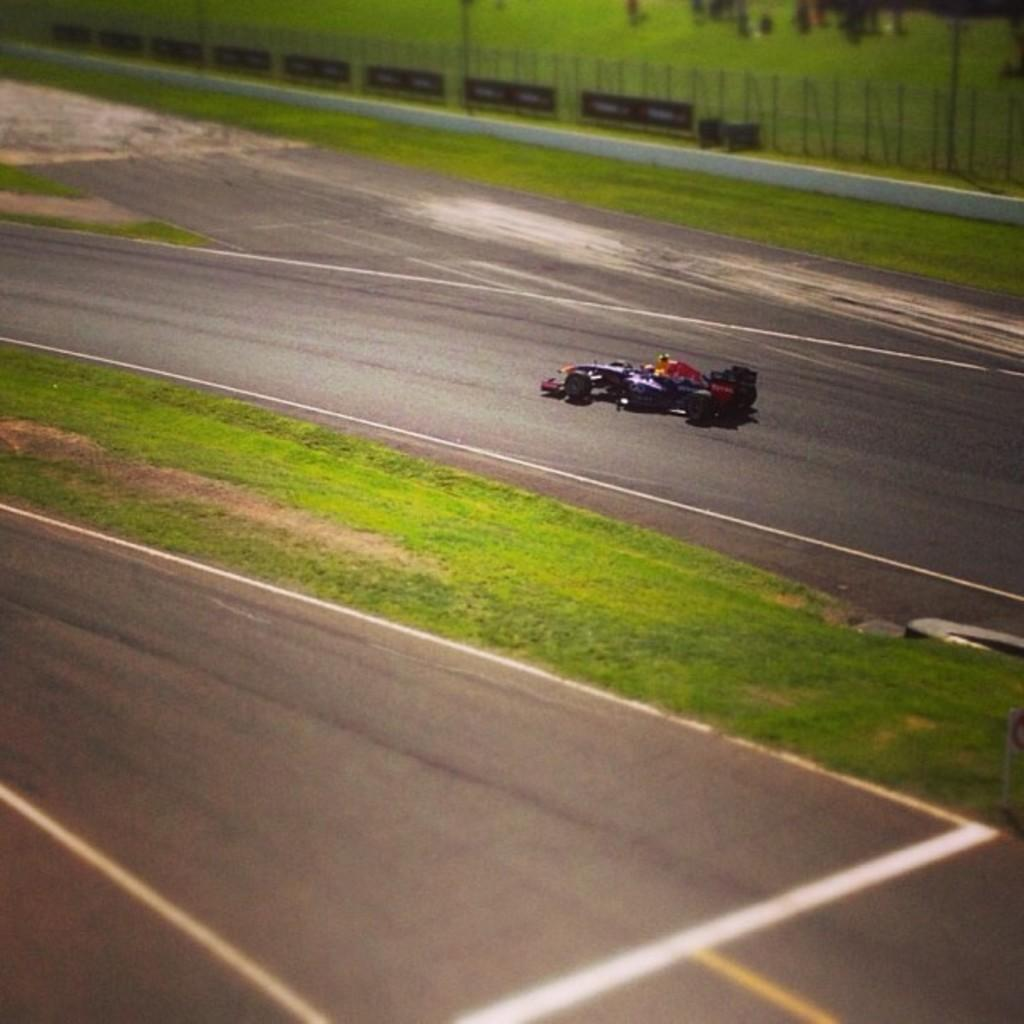What is the main subject in the image? There is a road in the image. What is located on the road in the image? There is a go-kart on the road. What can be seen in the background of the image? There is a fencing in the background of the image. Where can the fish be seen swimming in the image? There are no fish present in the image. What type of flooring is visible in the image? The image does not show any flooring, as it features a road and a go-kart on the road. 